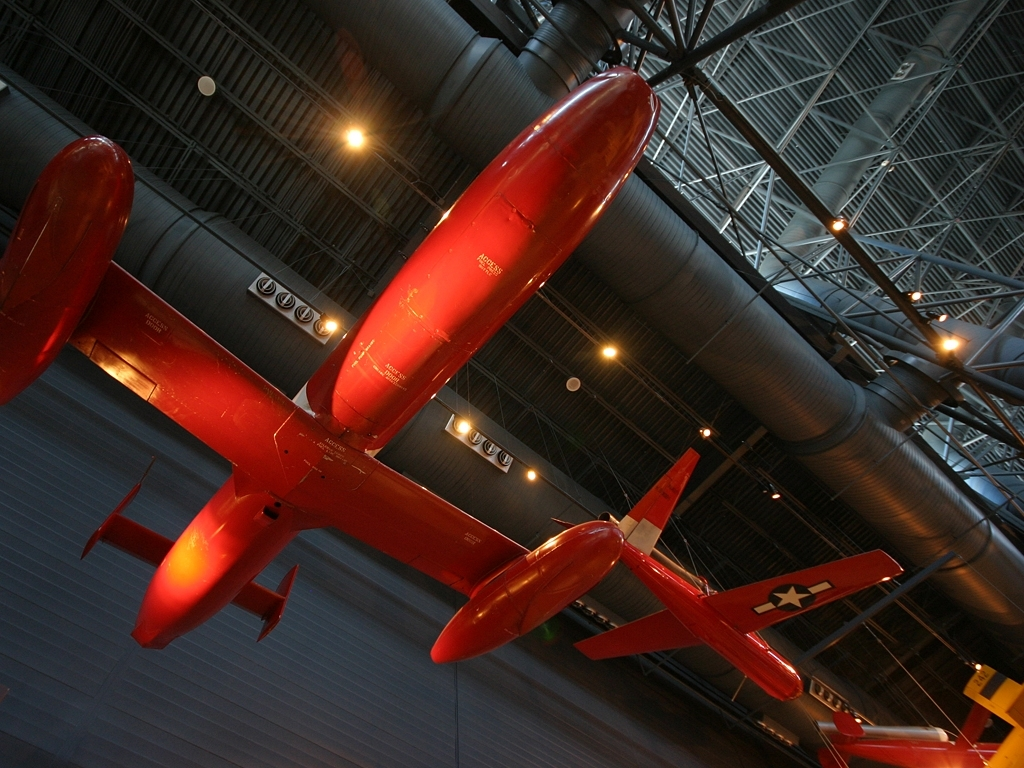Why might this plane be painted red? This aircraft is painted red for a few possible reasons: visibility, tradition, or aesthetics. Bright colors like red are easily seen against the sky and ground, which can be beneficial for safety. It might also be a traditional color for a racing team or manufacturer. Moreover, the vibrant color can make the plane more visually striking for display. What does the presence of multiple aircraft in one space suggest? Multiple aircraft displayed together in a museum setting suggest a curated collection that provides a narrative or historical timeline of aviation. It allows for the comparison of different designs and technologies, showcasing the evolution of flight and may also highlight various roles aircraft have played in society. 